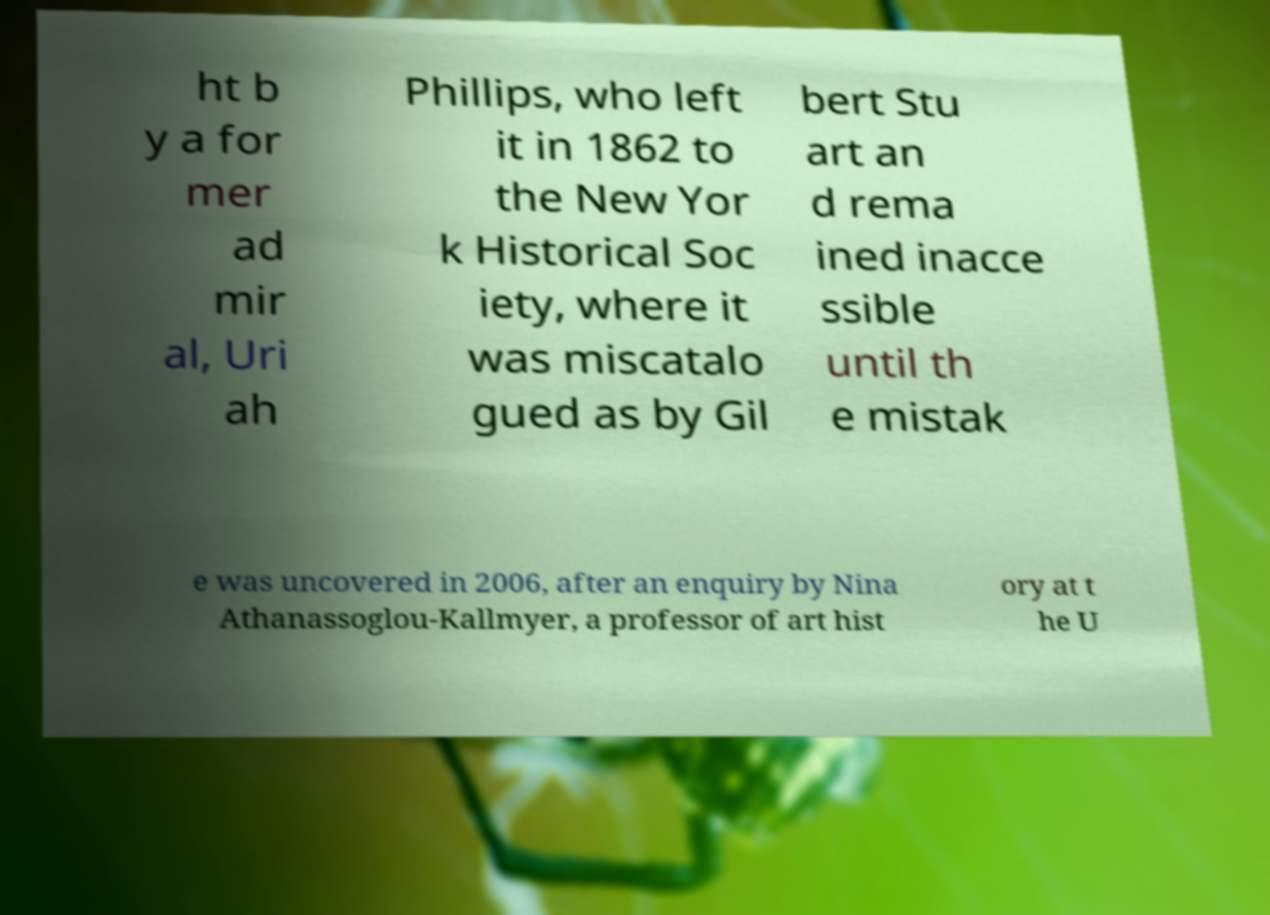What messages or text are displayed in this image? I need them in a readable, typed format. ht b y a for mer ad mir al, Uri ah Phillips, who left it in 1862 to the New Yor k Historical Soc iety, where it was miscatalo gued as by Gil bert Stu art an d rema ined inacce ssible until th e mistak e was uncovered in 2006, after an enquiry by Nina Athanassoglou-Kallmyer, a professor of art hist ory at t he U 